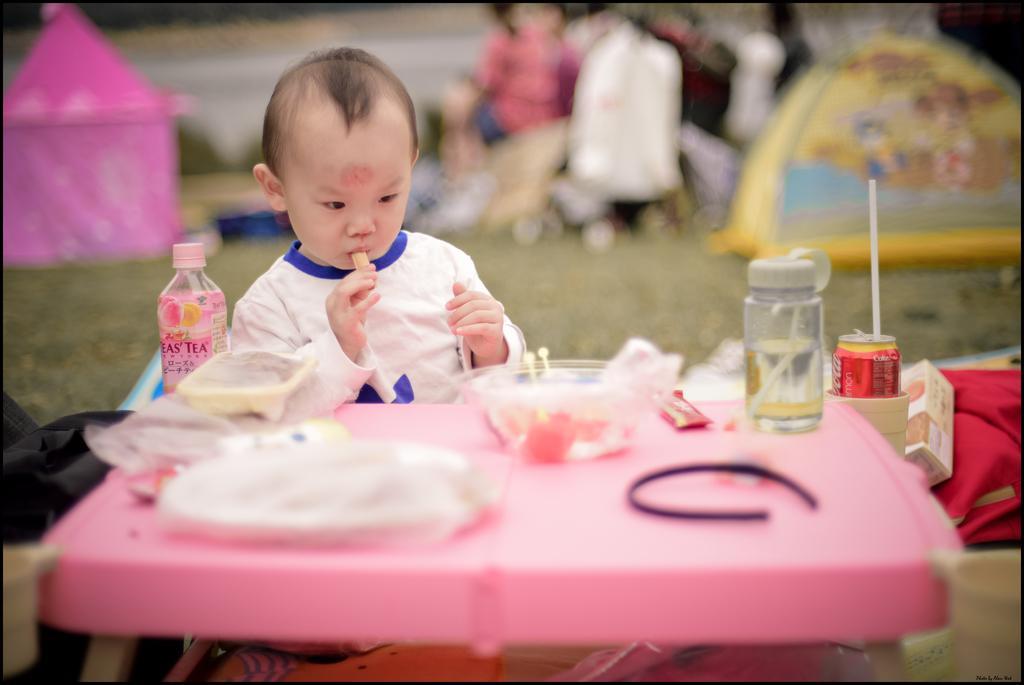In one or two sentences, can you explain what this image depicts? Here a boy is eating. In front of him there is a table,on the table there is a bottle,bowl,chocolate and etc. 